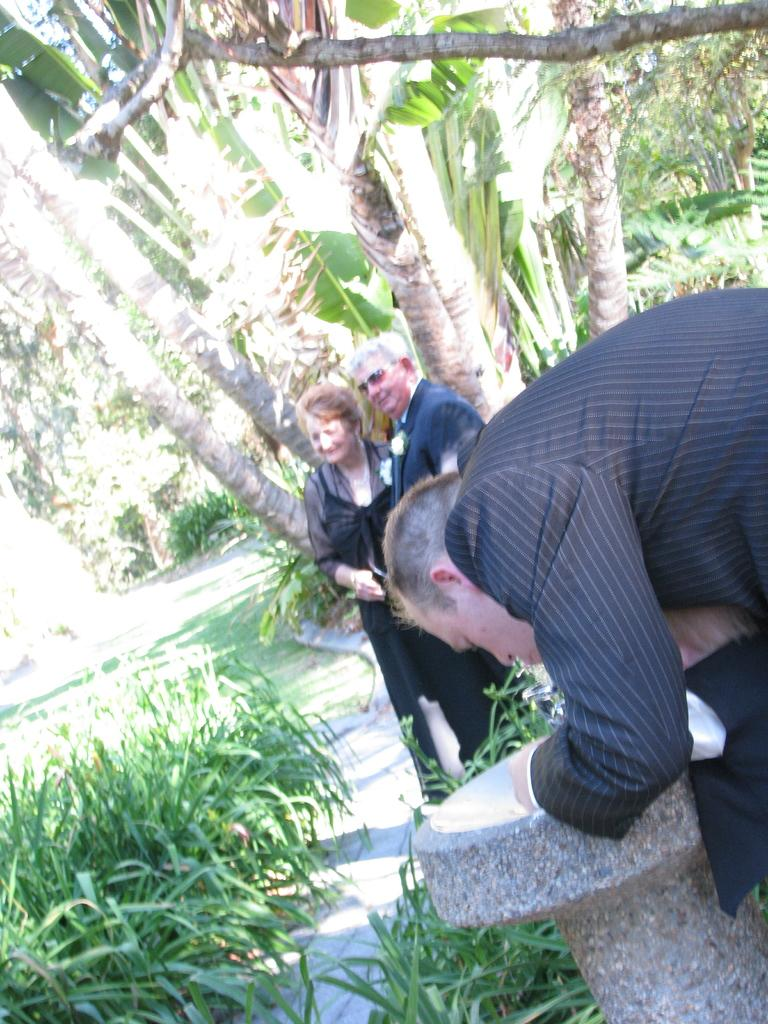What is the position of the person on the right side of the image? There is a person standing on the right side of the image. How many people are standing behind the person on the right side? There are two people standing behind the person on the right side. What can be seen in the background of the image? There are plants and trees in the background of the image. What type of coil is being used as a punishment in the image? There is no coil or punishment present in the image. What direction is the zephyr blowing in the image? There is no mention of a zephyr or wind in the image. 